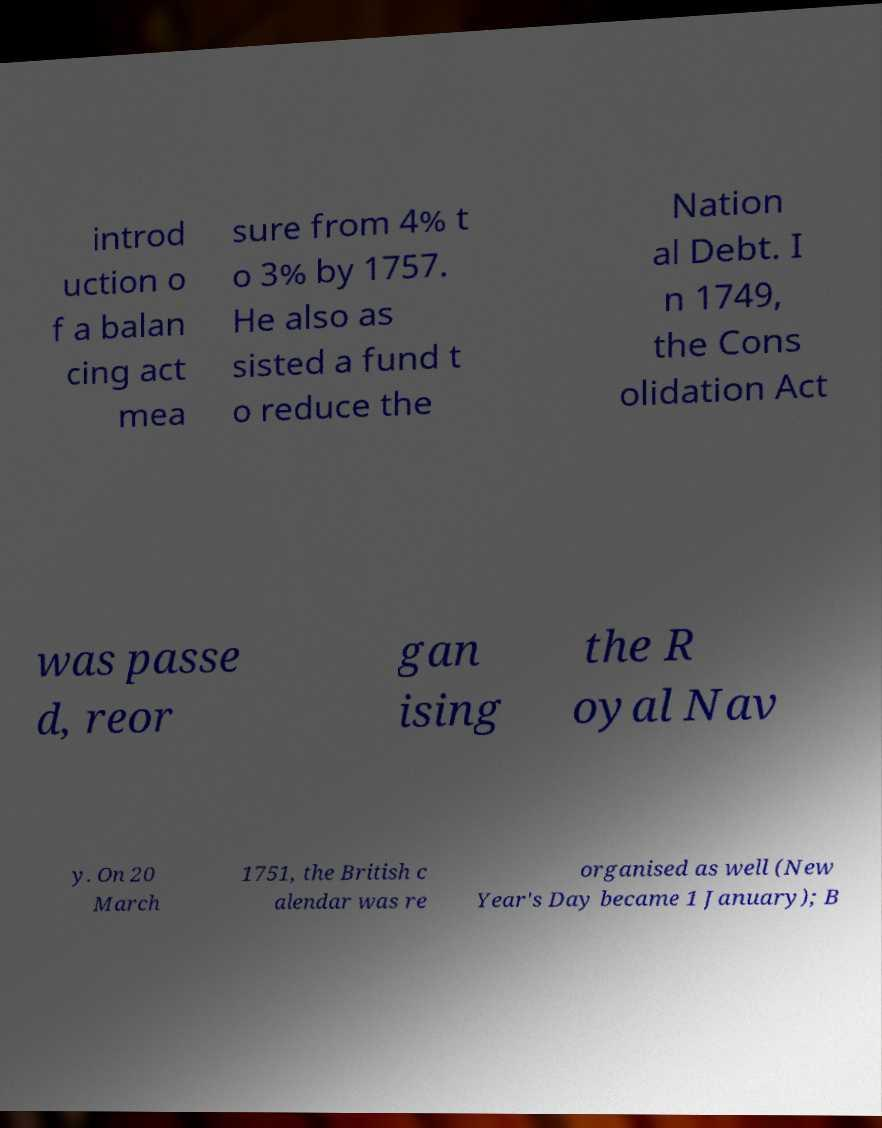Can you read and provide the text displayed in the image?This photo seems to have some interesting text. Can you extract and type it out for me? introd uction o f a balan cing act mea sure from 4% t o 3% by 1757. He also as sisted a fund t o reduce the Nation al Debt. I n 1749, the Cons olidation Act was passe d, reor gan ising the R oyal Nav y. On 20 March 1751, the British c alendar was re organised as well (New Year's Day became 1 January); B 